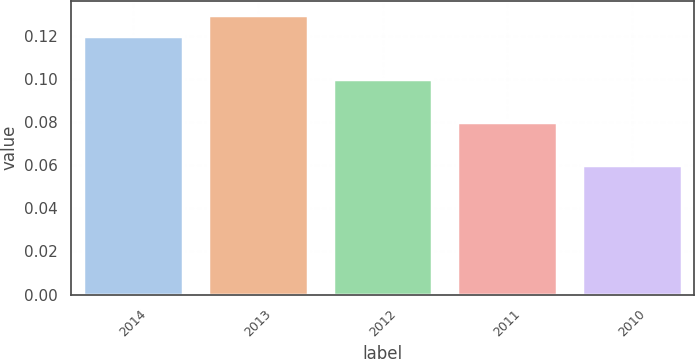<chart> <loc_0><loc_0><loc_500><loc_500><bar_chart><fcel>2014<fcel>2013<fcel>2012<fcel>2011<fcel>2010<nl><fcel>0.12<fcel>0.13<fcel>0.1<fcel>0.08<fcel>0.06<nl></chart> 